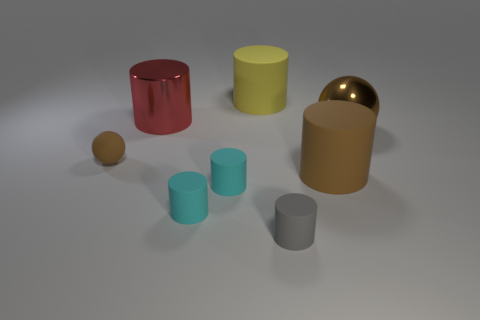The large thing that is both behind the brown matte cylinder and in front of the large shiny cylinder has what shape?
Make the answer very short. Sphere. Is there a blue shiny object that has the same size as the gray rubber cylinder?
Provide a succinct answer. No. How many things are big rubber objects that are on the right side of the yellow cylinder or large brown things?
Your answer should be compact. 2. Does the yellow thing have the same material as the brown sphere to the right of the large red shiny cylinder?
Your response must be concise. No. How many other things are the same shape as the big yellow rubber thing?
Offer a very short reply. 5. How many objects are big matte objects that are behind the big red cylinder or small cylinders to the left of the large yellow matte cylinder?
Provide a succinct answer. 3. How many other objects are there of the same color as the tiny sphere?
Your response must be concise. 2. Are there fewer large brown cylinders that are on the left side of the small gray rubber cylinder than matte objects that are behind the large brown metallic thing?
Ensure brevity in your answer.  Yes. What number of small balls are there?
Your answer should be compact. 1. There is a big yellow object that is the same shape as the tiny gray object; what material is it?
Offer a terse response. Rubber. 